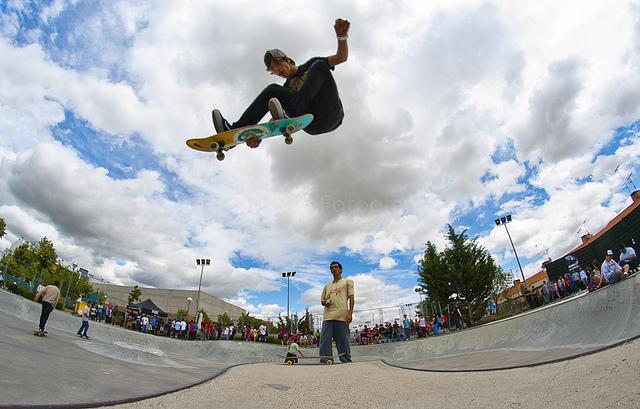How many skateboards are visible?
Give a very brief answer. 1. How many people are there?
Give a very brief answer. 3. How many giraffes are bent down?
Give a very brief answer. 0. 